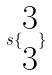<formula> <loc_0><loc_0><loc_500><loc_500>s \{ \begin{matrix} 3 \\ 3 \end{matrix} \}</formula> 